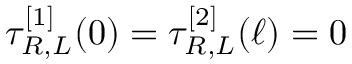<formula> <loc_0><loc_0><loc_500><loc_500>\tau _ { R , L } ^ { [ 1 ] } ( 0 ) = \tau _ { R , L } ^ { [ 2 ] } ( \ell ) = 0</formula> 